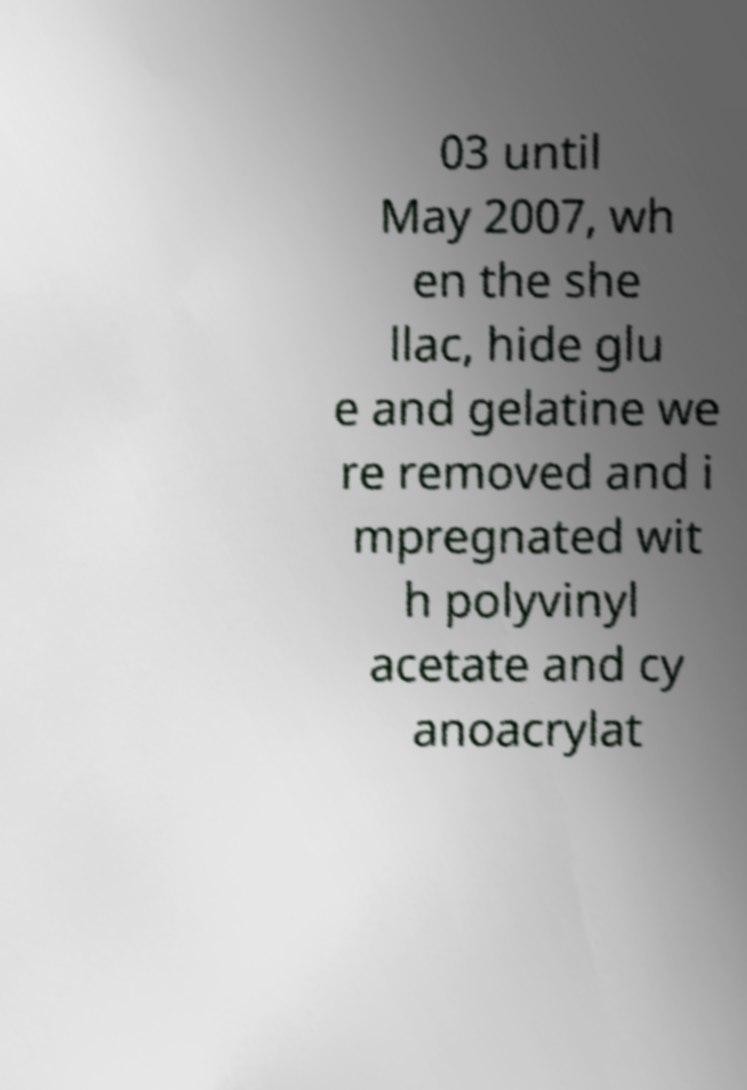What messages or text are displayed in this image? I need them in a readable, typed format. 03 until May 2007, wh en the she llac, hide glu e and gelatine we re removed and i mpregnated wit h polyvinyl acetate and cy anoacrylat 